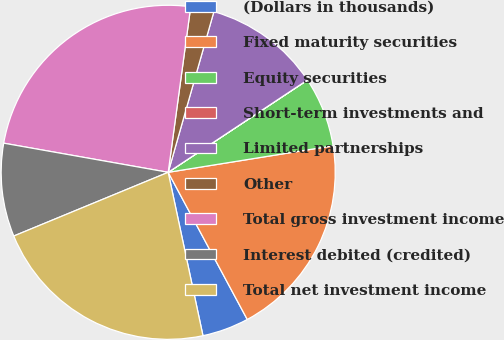Convert chart to OTSL. <chart><loc_0><loc_0><loc_500><loc_500><pie_chart><fcel>(Dollars in thousands)<fcel>Fixed maturity securities<fcel>Equity securities<fcel>Short-term investments and<fcel>Limited partnerships<fcel>Other<fcel>Total gross investment income<fcel>Interest debited (credited)<fcel>Total net investment income<nl><fcel>4.51%<fcel>19.69%<fcel>6.77%<fcel>0.01%<fcel>11.27%<fcel>2.26%<fcel>24.36%<fcel>9.02%<fcel>22.11%<nl></chart> 